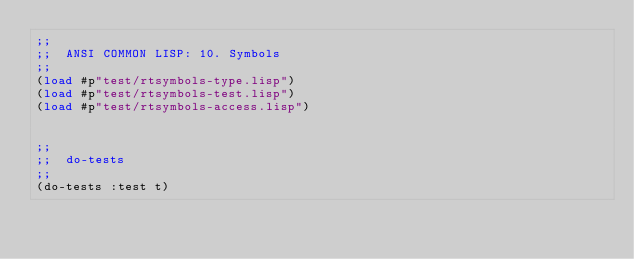Convert code to text. <code><loc_0><loc_0><loc_500><loc_500><_Lisp_>;;
;;  ANSI COMMON LISP: 10. Symbols
;;
(load #p"test/rtsymbols-type.lisp")
(load #p"test/rtsymbols-test.lisp")
(load #p"test/rtsymbols-access.lisp")


;;
;;  do-tests
;;
(do-tests :test t)

</code> 